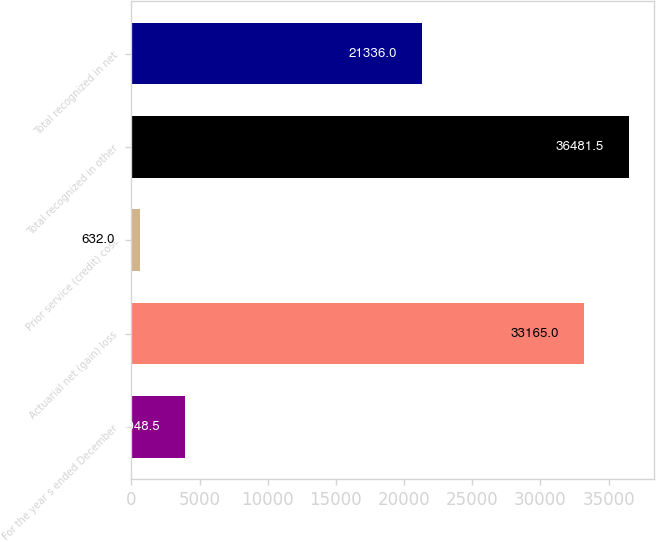Convert chart to OTSL. <chart><loc_0><loc_0><loc_500><loc_500><bar_chart><fcel>For the year s ended December<fcel>Actuarial net (gain) loss<fcel>Prior service (credit) cost<fcel>Total recognized in other<fcel>Total recognized in net<nl><fcel>3948.5<fcel>33165<fcel>632<fcel>36481.5<fcel>21336<nl></chart> 